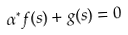<formula> <loc_0><loc_0><loc_500><loc_500>\alpha ^ { * } f ( s ) + g ( s ) = 0</formula> 